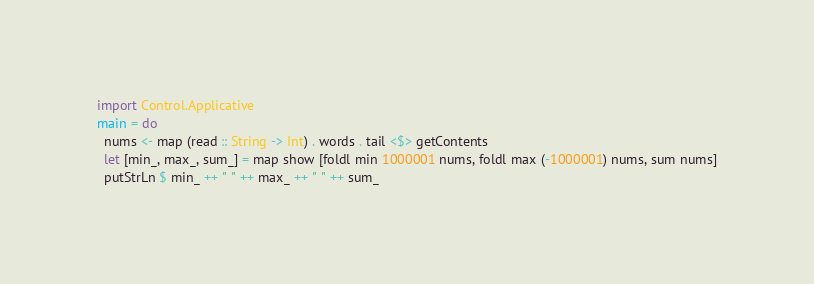Convert code to text. <code><loc_0><loc_0><loc_500><loc_500><_Haskell_>import Control.Applicative
main = do
  nums <- map (read :: String -> Int) . words . tail <$> getContents
  let [min_, max_, sum_] = map show [foldl min 1000001 nums, foldl max (-1000001) nums, sum nums]
  putStrLn $ min_ ++ " " ++ max_ ++ " " ++ sum_</code> 